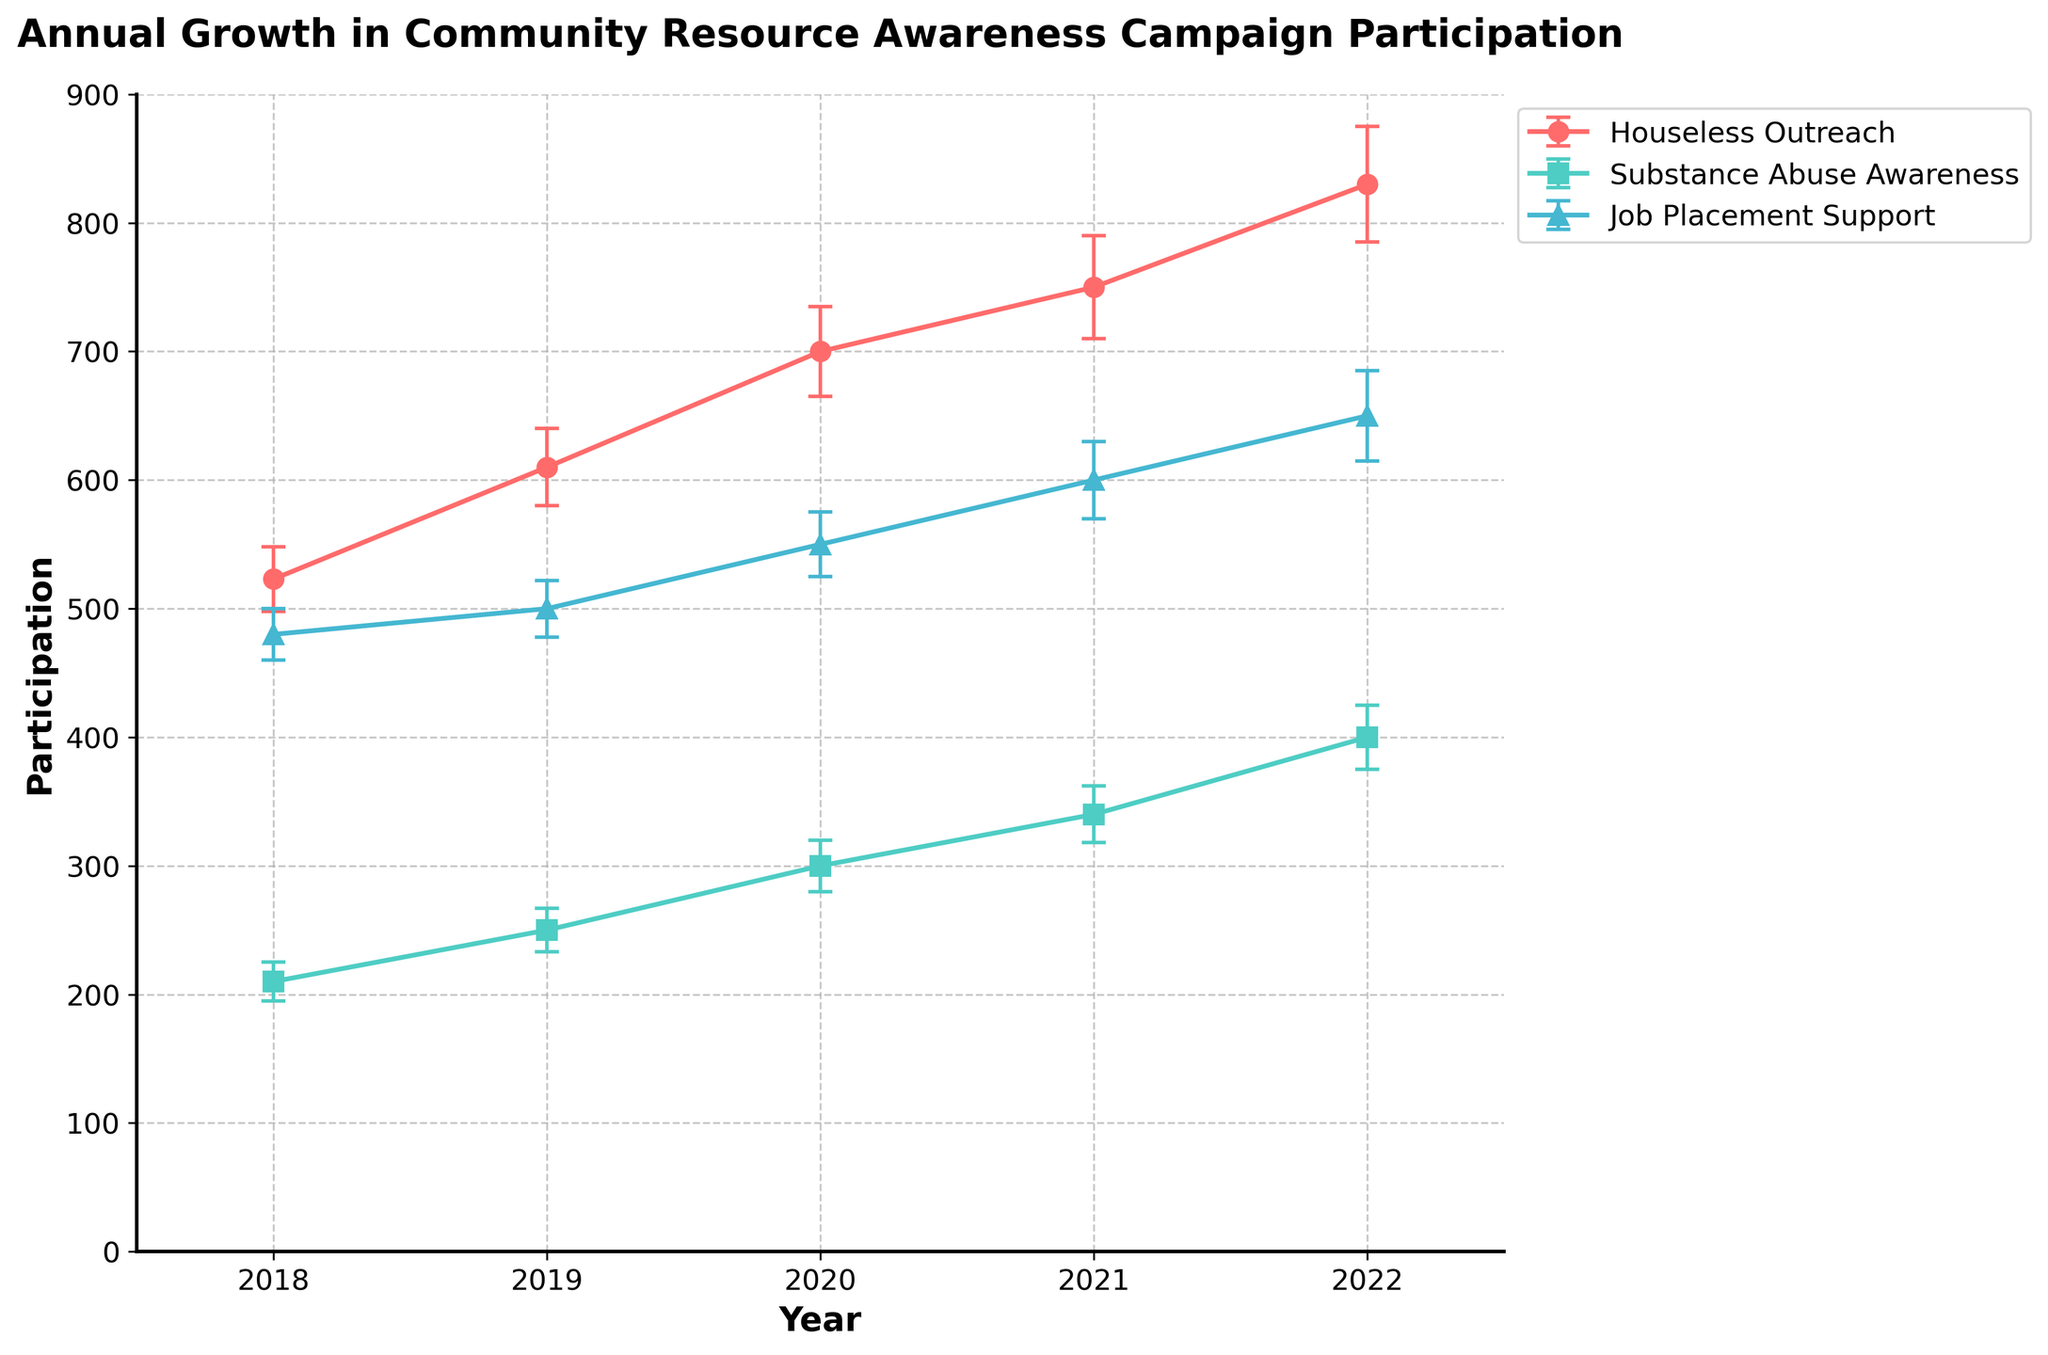what is the title of the figure? The title of the figure is typically displayed at the top of the plot and gives an overview of what the plot is about. The title of the figure is "Annual Growth in Community Resource Awareness Campaign Participation with Measurement Uncertainties."
Answer: "Annual Growth in Community Resource Awareness Campaign Participation" How many campaigns are compared in the figure? By examining the legend on the plot, we can determine the number of distinct campaigns being visualized. There are three campaigns: "Houseless Outreach," "Substance Abuse Awareness," and "Job Placement Support."
Answer: 3 Which campaign had the highest participation in 2022? By looking at the y-axis values for the year 2022, the campaign with the highest participation can be identified. "Houseless Outreach" had the highest participation in 2022 with approximately 830 participants.
Answer: Houseless Outreach How did participation in the "Substance Abuse Awareness" campaign change from 2019 to 2021? To answer this, we need to compare the participation values for the specific years in question. Participation in "Substance Abuse Awareness" was 250 in 2019 and increased to 340 by 2021, showing an increase of 90 participants.
Answer: Increased by 90 What is the average participation in the "Job Placement Support" campaign over the years presented? The participation values for "Job Placement Support" from 2018 to 2022 are: 480, 500, 550, 600, 650. Summing these up gives 2780, dividing by the number of years (5), we get the average as 2780 / 5 = 556.
Answer: 556 Which campaign showed the most consistent participation levels over the years? To determine consistency, we need to look at the variability and error bars for each campaign. "Job Placement Support" shows the most consistent participation levels, with relatively similar participation numbers and smaller error bars compared to the others.
Answer: Job Placement Support What is the uncertainty range for "Houseless Outreach" participation in 2021? The visualized error bars on the plot represent uncertainty. For "Houseless Outreach" in 2021, the participation is 750 with an error bar of 40, so the range is 710 to 790.
Answer: 710 to 790 Which year had the highest overall participation across all campaigns? Summing participation values across all campaigns for each year and comparing can determine the highest participation year. 2022 has the highest overall with participation in "Houseless Outreach" (830) + "Substance Abuse Awareness" (400) + "Job Placement Support" (650) = 1880.
Answer: 2022 How does the participation trend in "Houseless Outreach" compare to "Substance Abuse Awareness"? We need to compare the trends over the years for both campaigns. Both show an increasing trend, but "Houseless Outreach" has greater overall growth and participation values compared to "Substance Abuse Awareness."
Answer: Houseless Outreach shows greater growth What's the total participation increase for the "Substance Abuse Awareness" campaign from 2018 to 2022? The participation values for "Substance Abuse Awareness" are 210 in 2018 and 400 in 2022. The increase is 400 - 210 = 190 participants.
Answer: 190 